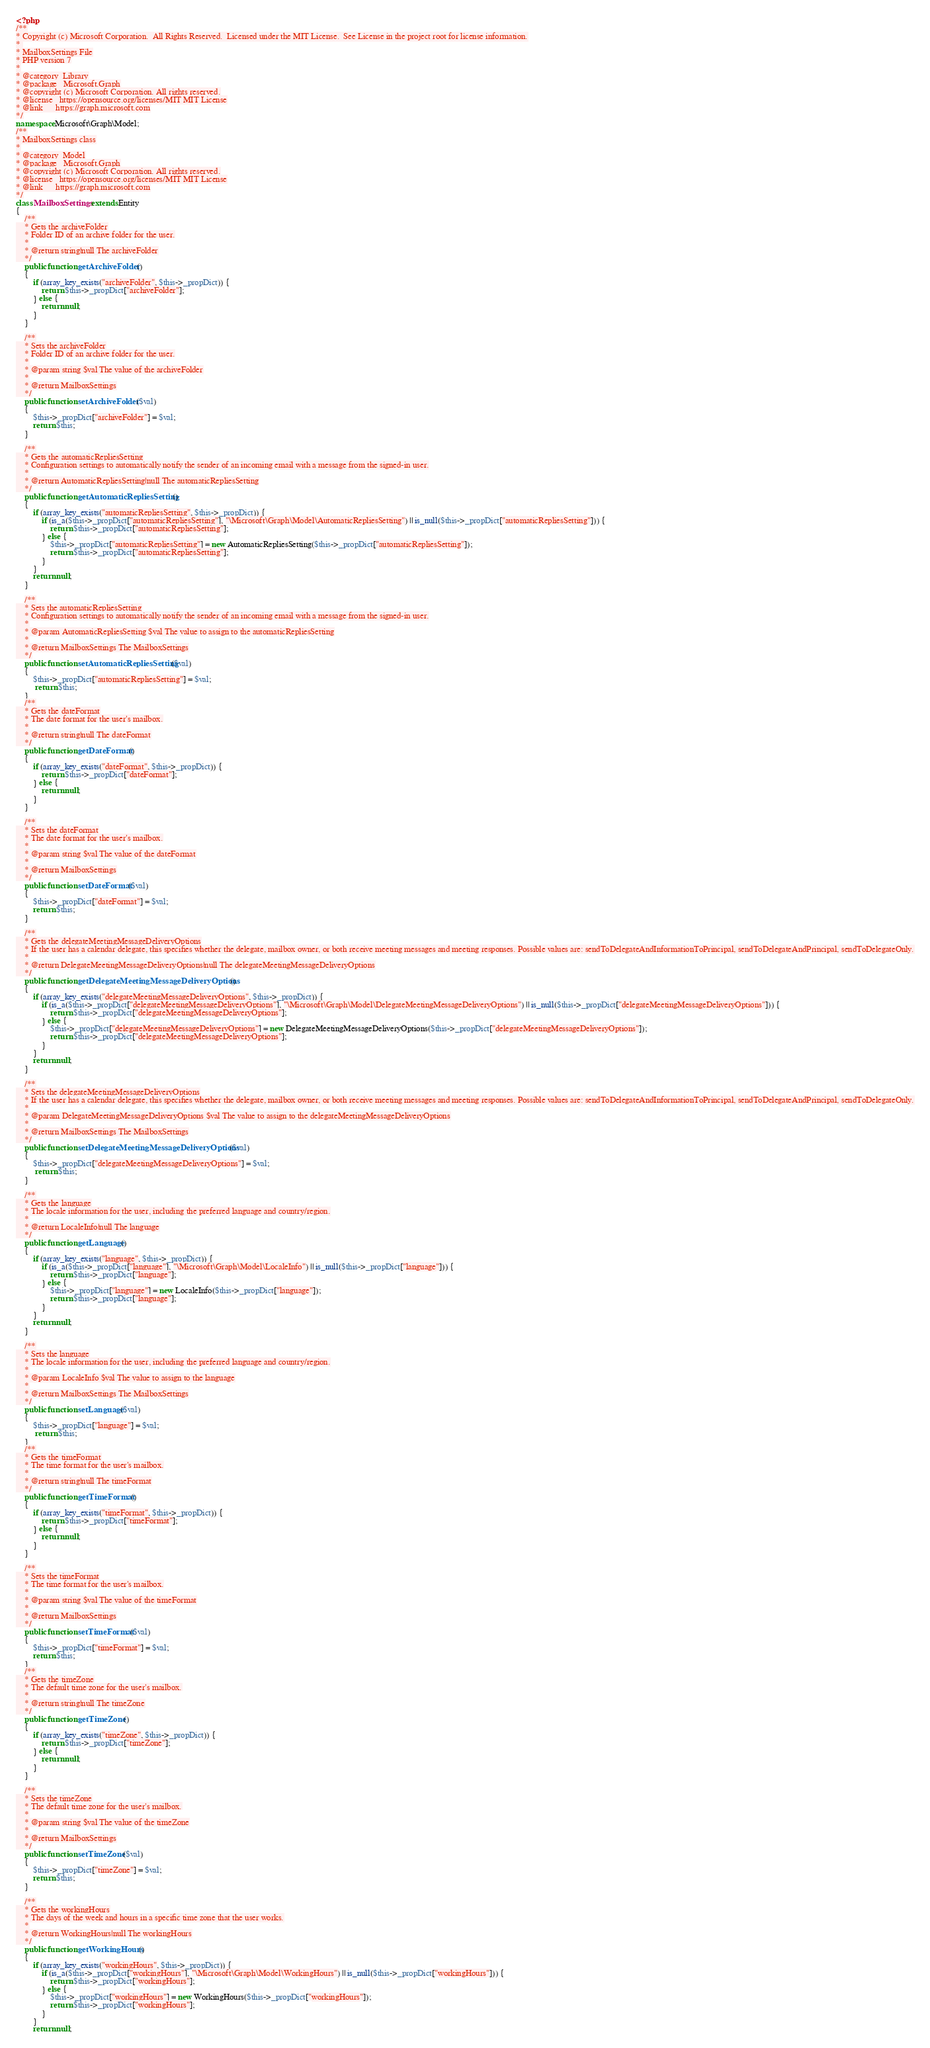<code> <loc_0><loc_0><loc_500><loc_500><_PHP_><?php
/**
* Copyright (c) Microsoft Corporation.  All Rights Reserved.  Licensed under the MIT License.  See License in the project root for license information.
* 
* MailboxSettings File
* PHP version 7
*
* @category  Library
* @package   Microsoft.Graph
* @copyright (c) Microsoft Corporation. All rights reserved.
* @license   https://opensource.org/licenses/MIT MIT License
* @link      https://graph.microsoft.com
*/
namespace Microsoft\Graph\Model;
/**
* MailboxSettings class
*
* @category  Model
* @package   Microsoft.Graph
* @copyright (c) Microsoft Corporation. All rights reserved.
* @license   https://opensource.org/licenses/MIT MIT License
* @link      https://graph.microsoft.com
*/
class MailboxSettings extends Entity
{
    /**
    * Gets the archiveFolder
    * Folder ID of an archive folder for the user.
    *
    * @return string|null The archiveFolder
    */
    public function getArchiveFolder()
    {
        if (array_key_exists("archiveFolder", $this->_propDict)) {
            return $this->_propDict["archiveFolder"];
        } else {
            return null;
        }
    }

    /**
    * Sets the archiveFolder
    * Folder ID of an archive folder for the user.
    *
    * @param string $val The value of the archiveFolder
    *
    * @return MailboxSettings
    */
    public function setArchiveFolder($val)
    {
        $this->_propDict["archiveFolder"] = $val;
        return $this;
    }

    /**
    * Gets the automaticRepliesSetting
    * Configuration settings to automatically notify the sender of an incoming email with a message from the signed-in user.
    *
    * @return AutomaticRepliesSetting|null The automaticRepliesSetting
    */
    public function getAutomaticRepliesSetting()
    {
        if (array_key_exists("automaticRepliesSetting", $this->_propDict)) {
            if (is_a($this->_propDict["automaticRepliesSetting"], "\Microsoft\Graph\Model\AutomaticRepliesSetting") || is_null($this->_propDict["automaticRepliesSetting"])) {
                return $this->_propDict["automaticRepliesSetting"];
            } else {
                $this->_propDict["automaticRepliesSetting"] = new AutomaticRepliesSetting($this->_propDict["automaticRepliesSetting"]);
                return $this->_propDict["automaticRepliesSetting"];
            }
        }
        return null;
    }

    /**
    * Sets the automaticRepliesSetting
    * Configuration settings to automatically notify the sender of an incoming email with a message from the signed-in user.
    *
    * @param AutomaticRepliesSetting $val The value to assign to the automaticRepliesSetting
    *
    * @return MailboxSettings The MailboxSettings
    */
    public function setAutomaticRepliesSetting($val)
    {
        $this->_propDict["automaticRepliesSetting"] = $val;
         return $this;
    }
    /**
    * Gets the dateFormat
    * The date format for the user's mailbox.
    *
    * @return string|null The dateFormat
    */
    public function getDateFormat()
    {
        if (array_key_exists("dateFormat", $this->_propDict)) {
            return $this->_propDict["dateFormat"];
        } else {
            return null;
        }
    }

    /**
    * Sets the dateFormat
    * The date format for the user's mailbox.
    *
    * @param string $val The value of the dateFormat
    *
    * @return MailboxSettings
    */
    public function setDateFormat($val)
    {
        $this->_propDict["dateFormat"] = $val;
        return $this;
    }

    /**
    * Gets the delegateMeetingMessageDeliveryOptions
    * If the user has a calendar delegate, this specifies whether the delegate, mailbox owner, or both receive meeting messages and meeting responses. Possible values are: sendToDelegateAndInformationToPrincipal, sendToDelegateAndPrincipal, sendToDelegateOnly.
    *
    * @return DelegateMeetingMessageDeliveryOptions|null The delegateMeetingMessageDeliveryOptions
    */
    public function getDelegateMeetingMessageDeliveryOptions()
    {
        if (array_key_exists("delegateMeetingMessageDeliveryOptions", $this->_propDict)) {
            if (is_a($this->_propDict["delegateMeetingMessageDeliveryOptions"], "\Microsoft\Graph\Model\DelegateMeetingMessageDeliveryOptions") || is_null($this->_propDict["delegateMeetingMessageDeliveryOptions"])) {
                return $this->_propDict["delegateMeetingMessageDeliveryOptions"];
            } else {
                $this->_propDict["delegateMeetingMessageDeliveryOptions"] = new DelegateMeetingMessageDeliveryOptions($this->_propDict["delegateMeetingMessageDeliveryOptions"]);
                return $this->_propDict["delegateMeetingMessageDeliveryOptions"];
            }
        }
        return null;
    }

    /**
    * Sets the delegateMeetingMessageDeliveryOptions
    * If the user has a calendar delegate, this specifies whether the delegate, mailbox owner, or both receive meeting messages and meeting responses. Possible values are: sendToDelegateAndInformationToPrincipal, sendToDelegateAndPrincipal, sendToDelegateOnly.
    *
    * @param DelegateMeetingMessageDeliveryOptions $val The value to assign to the delegateMeetingMessageDeliveryOptions
    *
    * @return MailboxSettings The MailboxSettings
    */
    public function setDelegateMeetingMessageDeliveryOptions($val)
    {
        $this->_propDict["delegateMeetingMessageDeliveryOptions"] = $val;
         return $this;
    }

    /**
    * Gets the language
    * The locale information for the user, including the preferred language and country/region.
    *
    * @return LocaleInfo|null The language
    */
    public function getLanguage()
    {
        if (array_key_exists("language", $this->_propDict)) {
            if (is_a($this->_propDict["language"], "\Microsoft\Graph\Model\LocaleInfo") || is_null($this->_propDict["language"])) {
                return $this->_propDict["language"];
            } else {
                $this->_propDict["language"] = new LocaleInfo($this->_propDict["language"]);
                return $this->_propDict["language"];
            }
        }
        return null;
    }

    /**
    * Sets the language
    * The locale information for the user, including the preferred language and country/region.
    *
    * @param LocaleInfo $val The value to assign to the language
    *
    * @return MailboxSettings The MailboxSettings
    */
    public function setLanguage($val)
    {
        $this->_propDict["language"] = $val;
         return $this;
    }
    /**
    * Gets the timeFormat
    * The time format for the user's mailbox.
    *
    * @return string|null The timeFormat
    */
    public function getTimeFormat()
    {
        if (array_key_exists("timeFormat", $this->_propDict)) {
            return $this->_propDict["timeFormat"];
        } else {
            return null;
        }
    }

    /**
    * Sets the timeFormat
    * The time format for the user's mailbox.
    *
    * @param string $val The value of the timeFormat
    *
    * @return MailboxSettings
    */
    public function setTimeFormat($val)
    {
        $this->_propDict["timeFormat"] = $val;
        return $this;
    }
    /**
    * Gets the timeZone
    * The default time zone for the user's mailbox.
    *
    * @return string|null The timeZone
    */
    public function getTimeZone()
    {
        if (array_key_exists("timeZone", $this->_propDict)) {
            return $this->_propDict["timeZone"];
        } else {
            return null;
        }
    }

    /**
    * Sets the timeZone
    * The default time zone for the user's mailbox.
    *
    * @param string $val The value of the timeZone
    *
    * @return MailboxSettings
    */
    public function setTimeZone($val)
    {
        $this->_propDict["timeZone"] = $val;
        return $this;
    }

    /**
    * Gets the workingHours
    * The days of the week and hours in a specific time zone that the user works.
    *
    * @return WorkingHours|null The workingHours
    */
    public function getWorkingHours()
    {
        if (array_key_exists("workingHours", $this->_propDict)) {
            if (is_a($this->_propDict["workingHours"], "\Microsoft\Graph\Model\WorkingHours") || is_null($this->_propDict["workingHours"])) {
                return $this->_propDict["workingHours"];
            } else {
                $this->_propDict["workingHours"] = new WorkingHours($this->_propDict["workingHours"]);
                return $this->_propDict["workingHours"];
            }
        }
        return null;</code> 